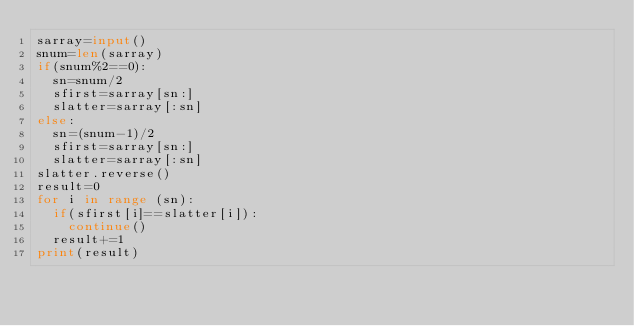Convert code to text. <code><loc_0><loc_0><loc_500><loc_500><_Python_>sarray=input()
snum=len(sarray)
if(snum%2==0):
  sn=snum/2
  sfirst=sarray[sn:]
  slatter=sarray[:sn]
else:
  sn=(snum-1)/2
  sfirst=sarray[sn:]
  slatter=sarray[:sn]
slatter.reverse()
result=0
for i in range (sn):
  if(sfirst[i]==slatter[i]):
    continue()
  result+=1
print(result)
  </code> 